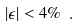Convert formula to latex. <formula><loc_0><loc_0><loc_500><loc_500>\left | \epsilon \right | < 4 \% \ .</formula> 